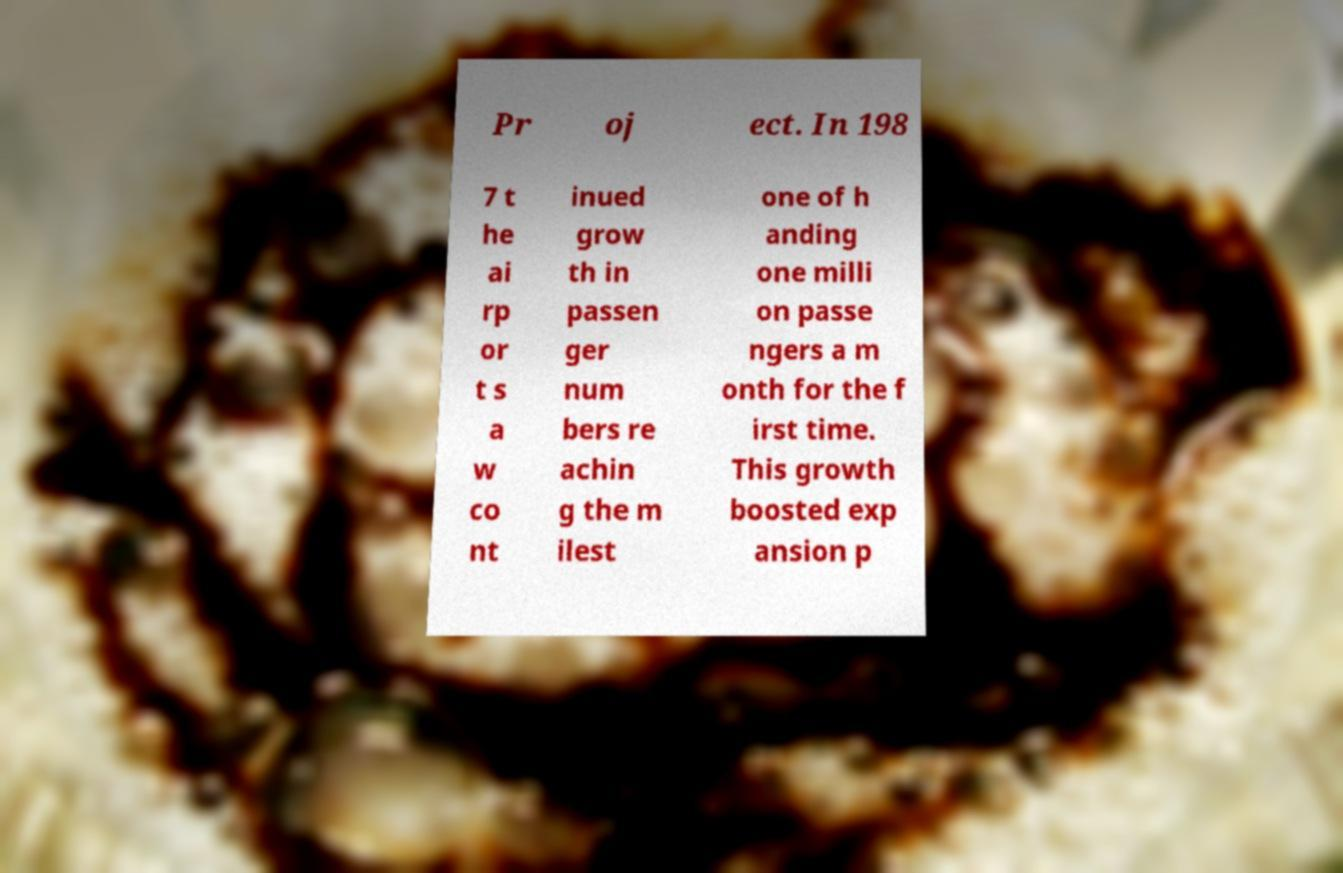What messages or text are displayed in this image? I need them in a readable, typed format. Pr oj ect. In 198 7 t he ai rp or t s a w co nt inued grow th in passen ger num bers re achin g the m ilest one of h anding one milli on passe ngers a m onth for the f irst time. This growth boosted exp ansion p 